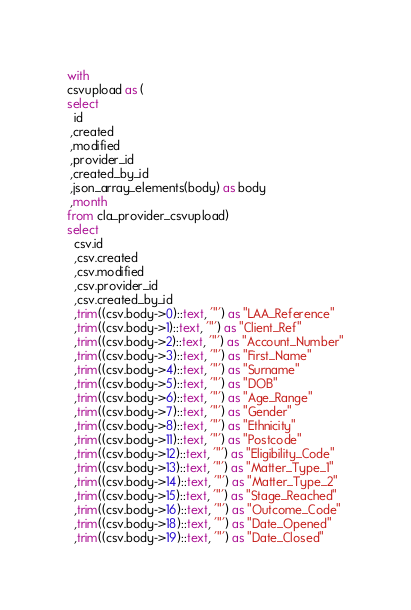Convert code to text. <code><loc_0><loc_0><loc_500><loc_500><_SQL_>with
csvupload as (
select
  id
 ,created
 ,modified
 ,provider_id
 ,created_by_id
 ,json_array_elements(body) as body
 ,month
from cla_provider_csvupload)
select
  csv.id
  ,csv.created
  ,csv.modified
  ,csv.provider_id
  ,csv.created_by_id
  ,trim((csv.body->0)::text, '"') as "LAA_Reference"
  ,trim((csv.body->1)::text, '"') as "Client_Ref"
  ,trim((csv.body->2)::text, '"') as "Account_Number"
  ,trim((csv.body->3)::text, '"') as "First_Name"
  ,trim((csv.body->4)::text, '"') as "Surname"
  ,trim((csv.body->5)::text, '"') as "DOB"
  ,trim((csv.body->6)::text, '"') as "Age_Range"
  ,trim((csv.body->7)::text, '"') as "Gender"
  ,trim((csv.body->8)::text, '"') as "Ethnicity"
  ,trim((csv.body->11)::text, '"') as "Postcode"
  ,trim((csv.body->12)::text, '"') as "Eligibility_Code"
  ,trim((csv.body->13)::text, '"') as "Matter_Type_1"
  ,trim((csv.body->14)::text, '"') as "Matter_Type_2"
  ,trim((csv.body->15)::text, '"') as "Stage_Reached"
  ,trim((csv.body->16)::text, '"') as "Outcome_Code"
  ,trim((csv.body->18)::text, '"') as "Date_Opened"
  ,trim((csv.body->19)::text, '"') as "Date_Closed"</code> 